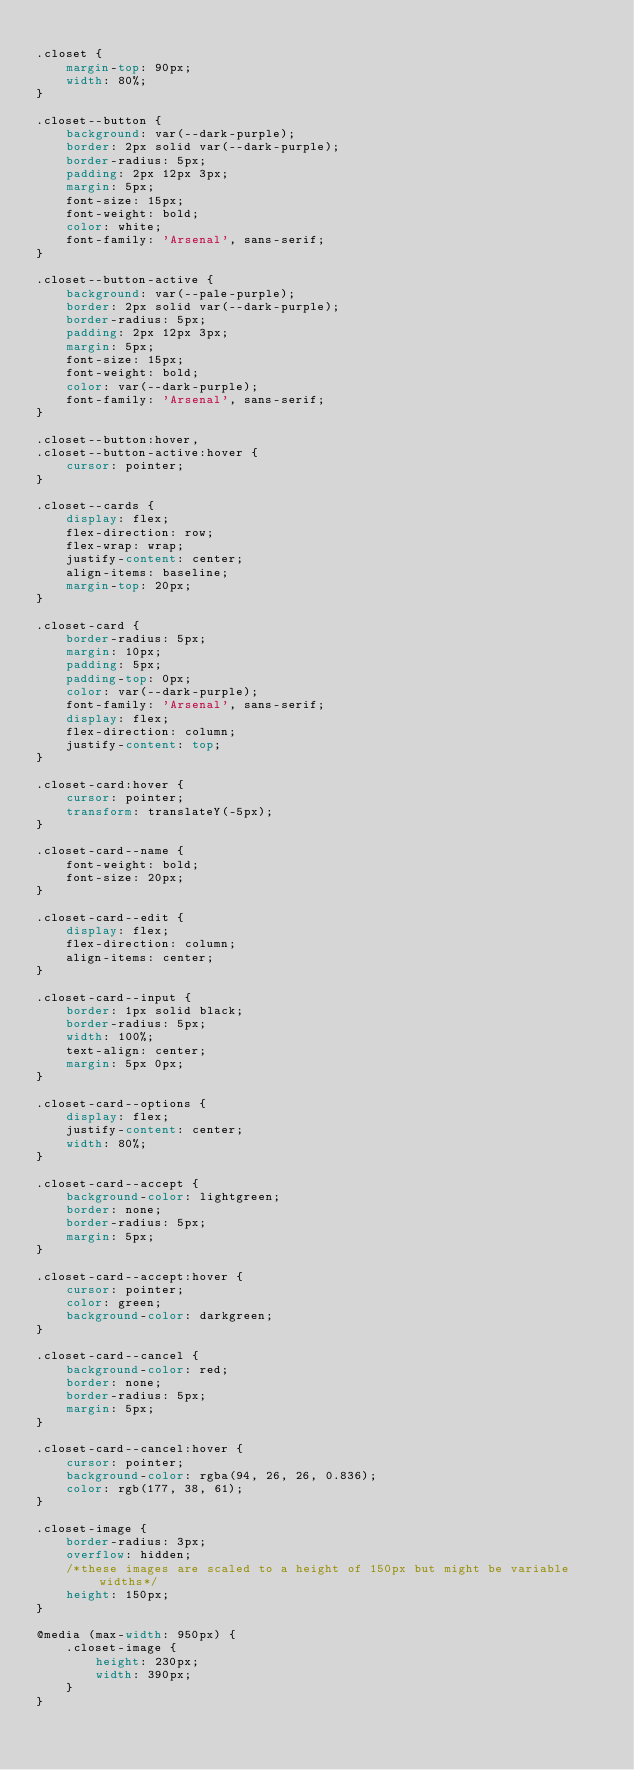<code> <loc_0><loc_0><loc_500><loc_500><_CSS_>
.closet {
	margin-top: 90px;
	width: 80%;
}

.closet--button {
	background: var(--dark-purple);
	border: 2px solid var(--dark-purple);
	border-radius: 5px;
	padding: 2px 12px 3px;
	margin: 5px;
	font-size: 15px;
	font-weight: bold;
	color: white;
	font-family: 'Arsenal', sans-serif;
}

.closet--button-active {
	background: var(--pale-purple);
	border: 2px solid var(--dark-purple);
	border-radius: 5px;
	padding: 2px 12px 3px;
	margin: 5px;
	font-size: 15px;
	font-weight: bold;
	color: var(--dark-purple);
	font-family: 'Arsenal', sans-serif;
}

.closet--button:hover,
.closet--button-active:hover {
	cursor: pointer;
}

.closet--cards {
	display: flex;
	flex-direction: row;
	flex-wrap: wrap;
	justify-content: center;
	align-items: baseline;
	margin-top: 20px;
}

.closet-card {
	border-radius: 5px;
	margin: 10px;
	padding: 5px;
	padding-top: 0px;
	color: var(--dark-purple);
	font-family: 'Arsenal', sans-serif;
	display: flex;
	flex-direction: column;
	justify-content: top;
}

.closet-card:hover {
	cursor: pointer;
	transform: translateY(-5px);
}

.closet-card--name {
	font-weight: bold;
	font-size: 20px;
}

.closet-card--edit {
	display: flex;
	flex-direction: column;
	align-items: center;
}

.closet-card--input {
	border: 1px solid black;
	border-radius: 5px;
	width: 100%;
	text-align: center;
	margin: 5px 0px;
}

.closet-card--options {
	display: flex;
	justify-content: center;
	width: 80%;
}

.closet-card--accept {
	background-color: lightgreen;
	border: none;
	border-radius: 5px;
	margin: 5px;
}

.closet-card--accept:hover {
	cursor: pointer;
	color: green;
	background-color: darkgreen;
}

.closet-card--cancel {
	background-color: red;
	border: none;
	border-radius: 5px;
	margin: 5px;
}

.closet-card--cancel:hover {
	cursor: pointer;
	background-color: rgba(94, 26, 26, 0.836);
	color: rgb(177, 38, 61);
}

.closet-image {
	border-radius: 3px;
	overflow: hidden;
	/*these images are scaled to a height of 150px but might be variable widths*/
	height: 150px;
}

@media (max-width: 950px) {
	.closet-image {
		height: 230px;
		width: 390px;
	}
}
</code> 